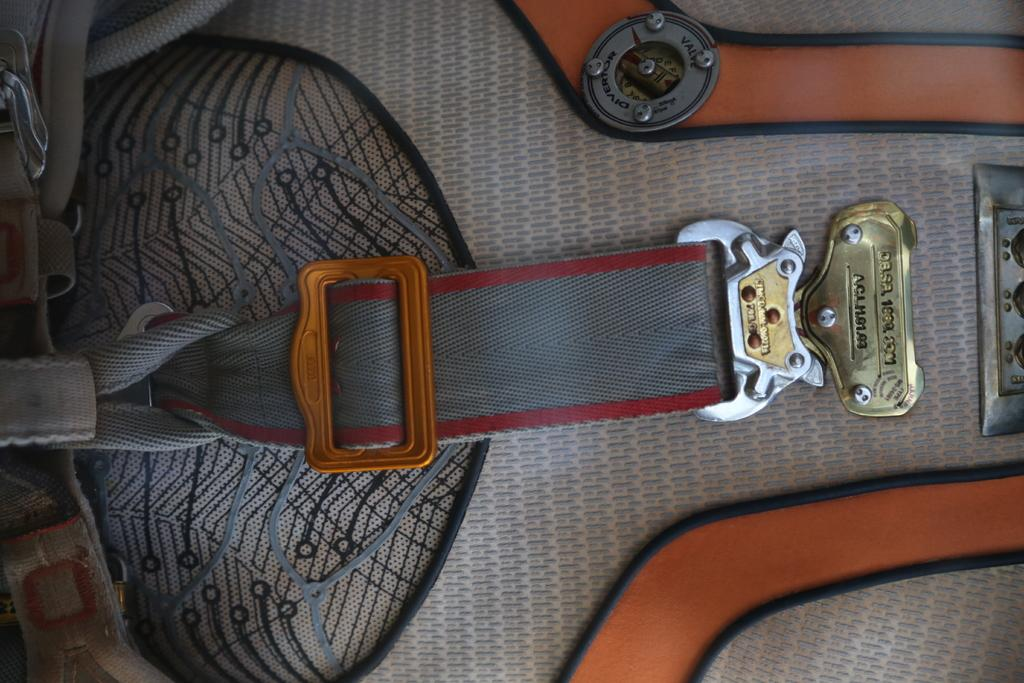What object can be seen in the image that might be used for carrying items? There is a bag in the image that might be used for carrying items. What accessory is visible in the image that is typically used to hold up pants? There is a belt visible in the image that is typically used to hold up pants. What color feature can be observed on the bag in the image? The bag has orange color strips. Is there a fight happening in the image? No, there is no fight depicted in the image. Can you see a sail in the image? No, there is no sail present in the image. 